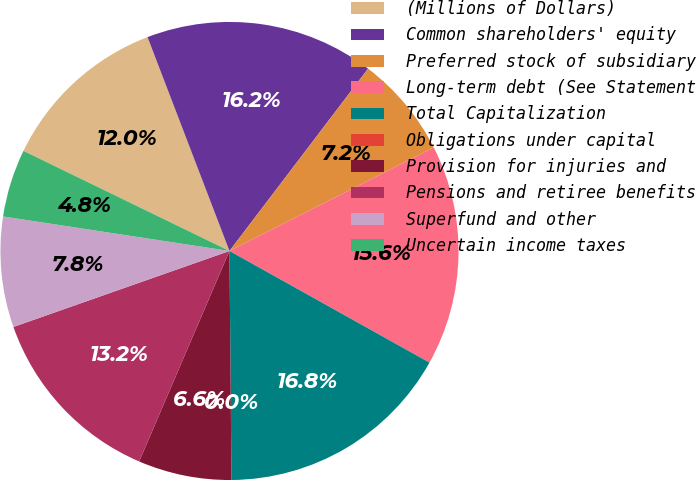Convert chart to OTSL. <chart><loc_0><loc_0><loc_500><loc_500><pie_chart><fcel>(Millions of Dollars)<fcel>Common shareholders' equity<fcel>Preferred stock of subsidiary<fcel>Long-term debt (See Statement<fcel>Total Capitalization<fcel>Obligations under capital<fcel>Provision for injuries and<fcel>Pensions and retiree benefits<fcel>Superfund and other<fcel>Uncertain income taxes<nl><fcel>11.98%<fcel>16.17%<fcel>7.19%<fcel>15.57%<fcel>16.76%<fcel>0.0%<fcel>6.59%<fcel>13.17%<fcel>7.79%<fcel>4.79%<nl></chart> 